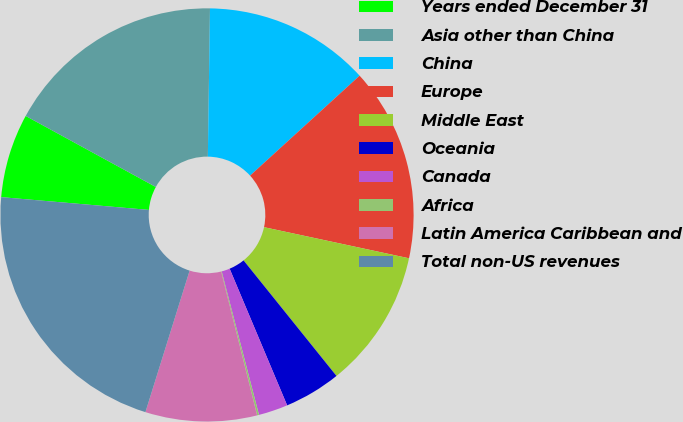Convert chart. <chart><loc_0><loc_0><loc_500><loc_500><pie_chart><fcel>Years ended December 31<fcel>Asia other than China<fcel>China<fcel>Europe<fcel>Middle East<fcel>Oceania<fcel>Canada<fcel>Africa<fcel>Latin America Caribbean and<fcel>Total non-US revenues<nl><fcel>6.58%<fcel>17.28%<fcel>13.0%<fcel>15.14%<fcel>10.86%<fcel>4.44%<fcel>2.29%<fcel>0.15%<fcel>8.72%<fcel>21.56%<nl></chart> 